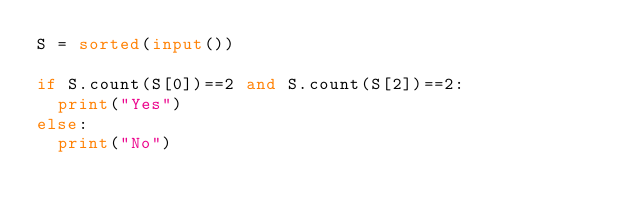<code> <loc_0><loc_0><loc_500><loc_500><_Python_>S = sorted(input())

if S.count(S[0])==2 and S.count(S[2])==2:
  print("Yes")
else:
  print("No")</code> 